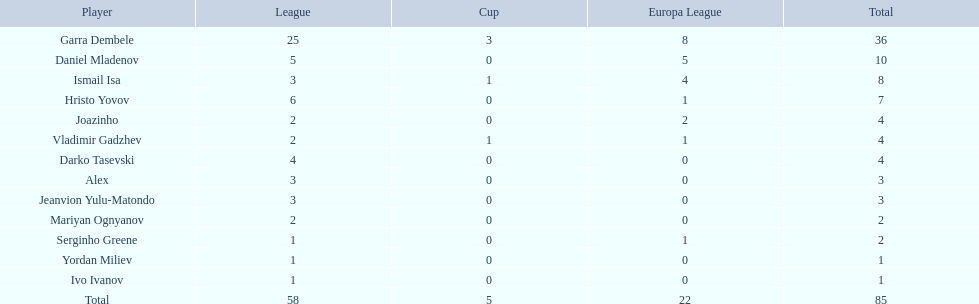How many goals did ismail isa score this season? 8. 